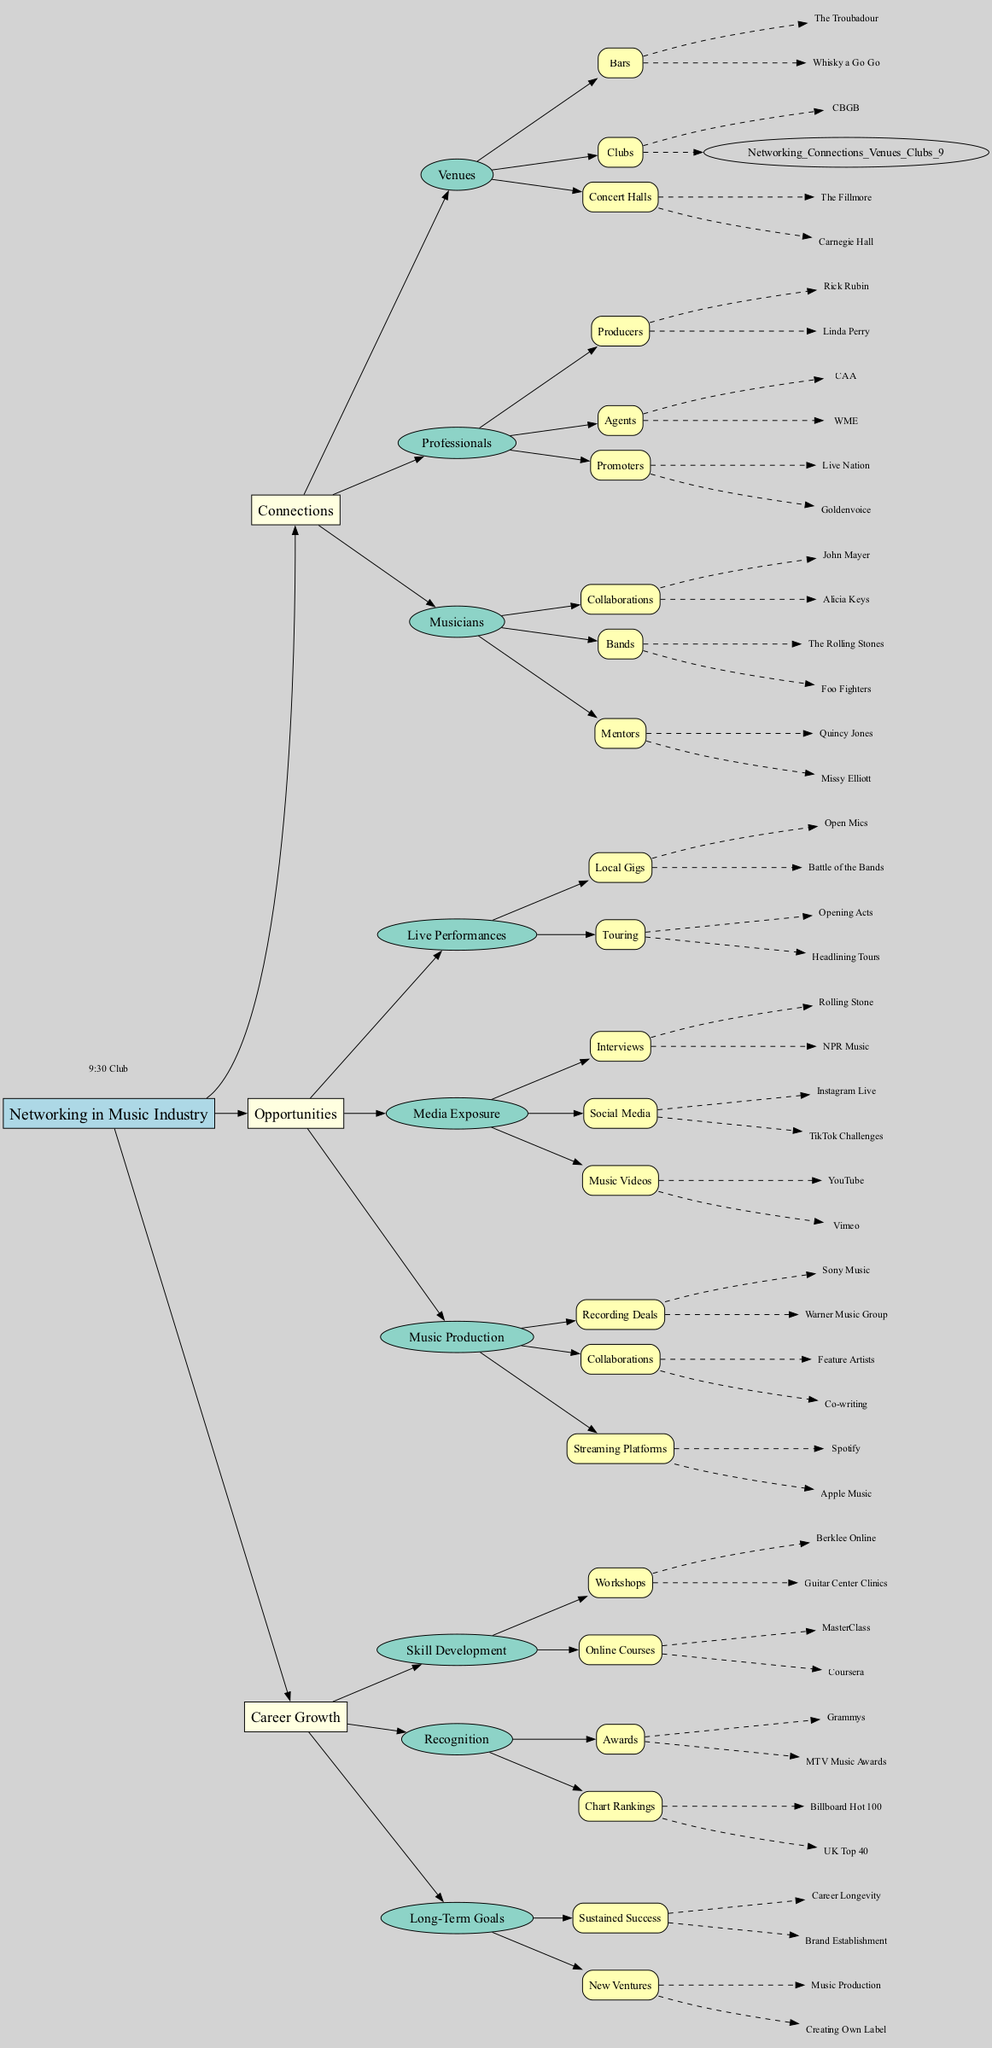What are the two types of venues listed under Connections? The diagram shows different types of venues listed under the Connections category. Two specific types mentioned are "Bars" and "Clubs."
Answer: Bars, Clubs How many producers are listed under the Professionals connection? To find the answer, we look under the Professionals section and count the number of entries listed under Producers, which are Rick Rubin and Linda Perry. There are two producers.
Answer: 2 What is one media exposure opportunity shown in the diagram? The Media Exposure section contains various opportunities, and looking closely, one specific opportunity listed is "Interviews."
Answer: Interviews Which renowned mentor is mentioned in the Musicians connections? Under the Musicians category, one of the listed mentors is Quincy Jones, recognized for his influence and success in the industry.
Answer: Quincy Jones What combination of opportunities contributes to career growth according to the diagram? The diagram outlines that both "Skill Development" and "Recognition" are key components contributing to Career Growth. By analyzing the connections under Career Growth, one sees that both lead to advancements in an artist's career.
Answer: Skill Development, Recognition Which major award is listed under Recognition? Under the Recognition category, one of the notable awards listed is the "Grammys," a prestigious accolade in the music industry.
Answer: Grammys What type of local gigs are mentioned as a live performance opportunity? The diagram highlights various live performance opportunities. Under Local Gigs, specific mentions include "Open Mics," which are events allowing musicians to perform live.
Answer: Open Mics How many categories are there under Opportunities? By reviewing the Opportunities section in the diagram, we see there are three clear categories: Live Performances, Media Exposure, and Music Production. Thus, we count them and find there are three categories total.
Answer: 3 What are the Streaming Platforms mentioned that contribute to music production? Within the Music Production opportunities, the diagram identifies "Spotify" and "Apple Music" as specific platforms contributing to the digital distribution of music.
Answer: Spotify, Apple Music 